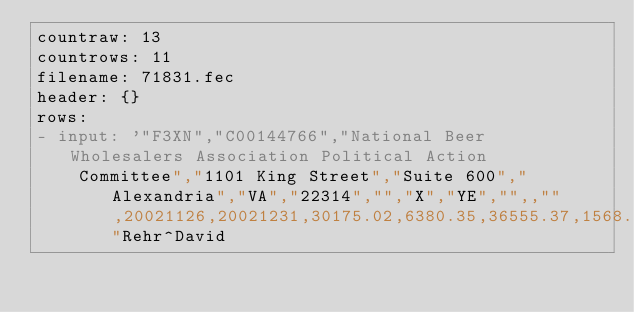Convert code to text. <code><loc_0><loc_0><loc_500><loc_500><_YAML_>countraw: 13
countrows: 11
filename: 71831.fec
header: {}
rows:
- input: '"F3XN","C00144766","National Beer Wholesalers Association Political Action
    Committee","1101 King Street","Suite 600","Alexandria","VA","22314","","X","YE","",,"",20021126,20021231,30175.02,6380.35,36555.37,1568.01,34987.36,0.00,0.00,1000.00,200.00,1200.00,0.00,0.00,1200.00,0.00,0.00,0.00,0.00,5000.00,180.35,0.00,6380.35,6380.35,0.00,0.00,68.01,68.01,0.00,1500.00,0.00,0.00,0.00,0.00,0.00,0.00,0.00,0.00,0.00,1568.01,1568.01,1200.00,0.00,1200.00,68.01,0.00,68.01,420204.82,2002,1197710.37,1617915.19,1582927.83,34987.36,1111523.00,52771.25,1164294.25,0.00,8000.00,1172294.25,0.00,0.00,0.00,0.00,18000.00,7416.12,0.00,1197710.37,1197710.37,0.00,0.00,4677.83,4677.83,0.00,1578250.00,0.00,0.00,0.00,0.00,0.00,0.00,0.00,0.00,0.00,1582927.83,1582927.83,1172294.25,0.00,1172294.25,4677.83,0.00,4677.83,"Rehr^David</code> 